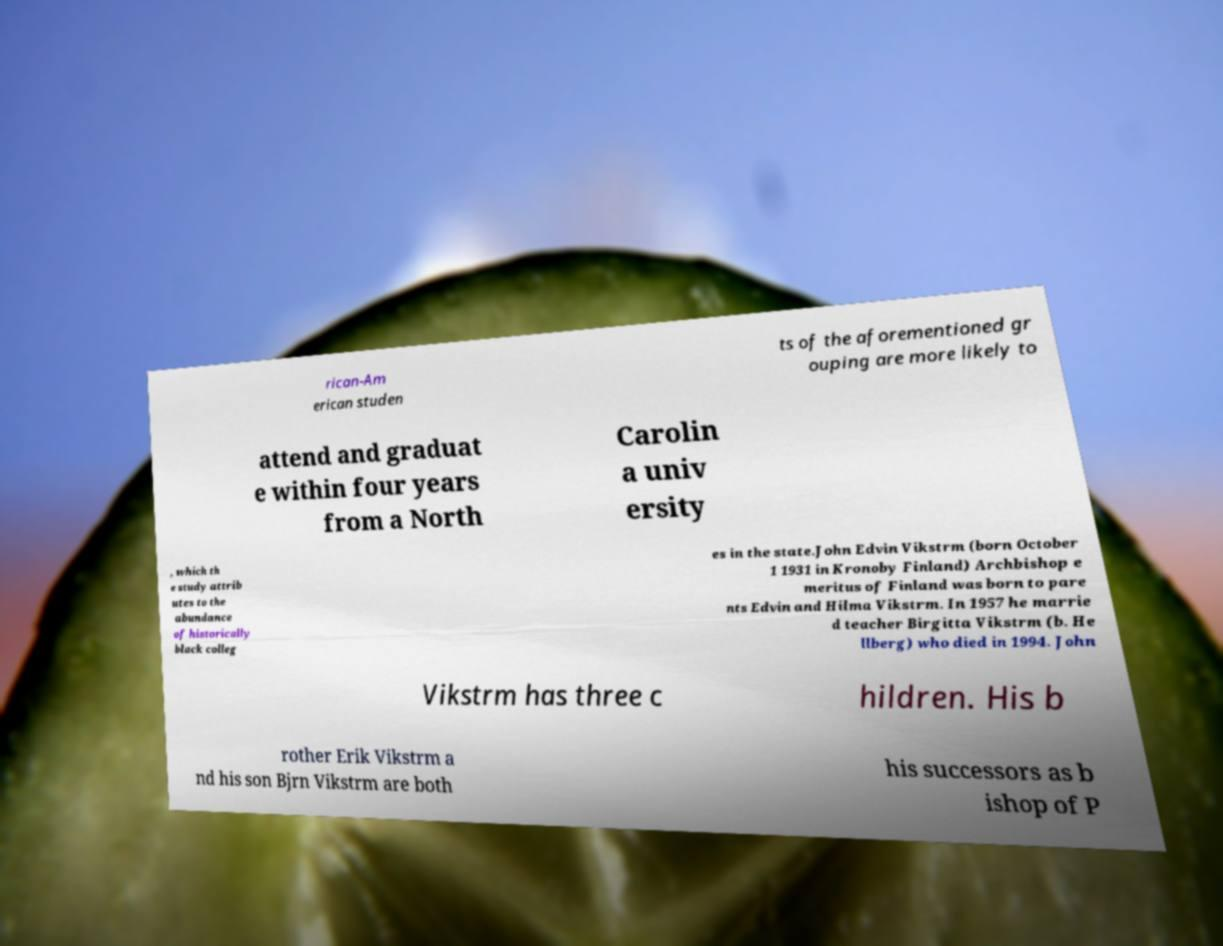Could you assist in decoding the text presented in this image and type it out clearly? rican-Am erican studen ts of the aforementioned gr ouping are more likely to attend and graduat e within four years from a North Carolin a univ ersity , which th e study attrib utes to the abundance of historically black colleg es in the state.John Edvin Vikstrm (born October 1 1931 in Kronoby Finland) Archbishop e meritus of Finland was born to pare nts Edvin and Hilma Vikstrm. In 1957 he marrie d teacher Birgitta Vikstrm (b. He llberg) who died in 1994. John Vikstrm has three c hildren. His b rother Erik Vikstrm a nd his son Bjrn Vikstrm are both his successors as b ishop of P 